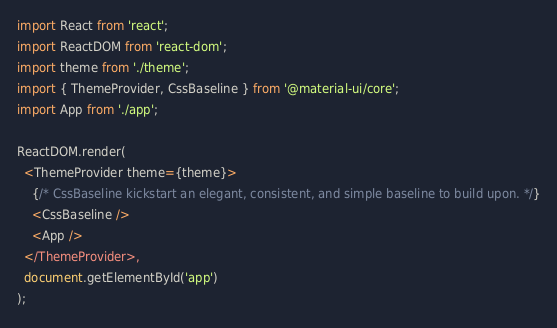Convert code to text. <code><loc_0><loc_0><loc_500><loc_500><_TypeScript_>import React from 'react';
import ReactDOM from 'react-dom';
import theme from './theme';
import { ThemeProvider, CssBaseline } from '@material-ui/core';
import App from './app';

ReactDOM.render(
  <ThemeProvider theme={theme}>
    {/* CssBaseline kickstart an elegant, consistent, and simple baseline to build upon. */}
    <CssBaseline />
    <App />
  </ThemeProvider>,
  document.getElementById('app')
);
</code> 